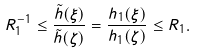<formula> <loc_0><loc_0><loc_500><loc_500>R _ { 1 } ^ { - 1 } \leq \frac { \tilde { h } ( \xi ) } { \tilde { h } ( \zeta ) } = \frac { h _ { 1 } ( \xi ) } { h _ { 1 } ( \zeta ) } \leq R _ { 1 } .</formula> 